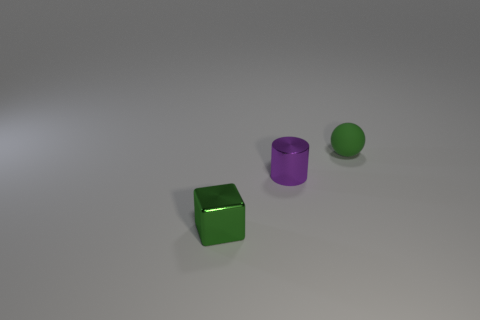There is a matte thing; what shape is it?
Make the answer very short. Sphere. There is a tiny object that is behind the green metal block and in front of the tiny green sphere; what material is it?
Your answer should be very brief. Metal. What shape is the purple thing that is the same material as the green cube?
Offer a very short reply. Cylinder. There is a object that is the same material as the tiny cylinder; what is its size?
Give a very brief answer. Small. The tiny object that is both behind the green metal object and in front of the small rubber object has what shape?
Your response must be concise. Cylinder. How big is the green thing behind the shiny thing that is in front of the purple metallic cylinder?
Give a very brief answer. Small. How many other things are the same color as the rubber sphere?
Your answer should be compact. 1. What is the material of the tiny green ball?
Keep it short and to the point. Rubber. Are there any small rubber things?
Provide a short and direct response. Yes. Is the number of purple shiny cylinders that are in front of the tiny purple metallic object the same as the number of big cyan rubber cubes?
Your response must be concise. Yes. 